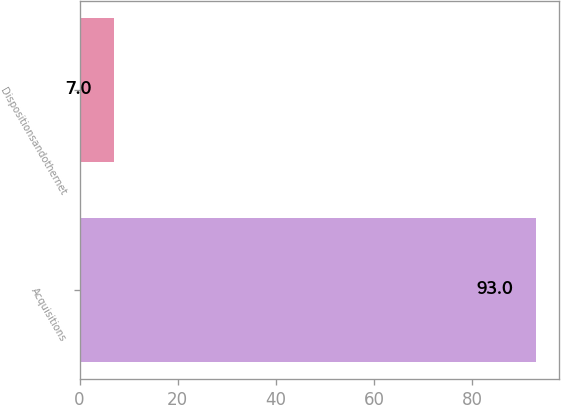Convert chart to OTSL. <chart><loc_0><loc_0><loc_500><loc_500><bar_chart><fcel>Acquisitions<fcel>Dispositionsandothernet<nl><fcel>93<fcel>7<nl></chart> 